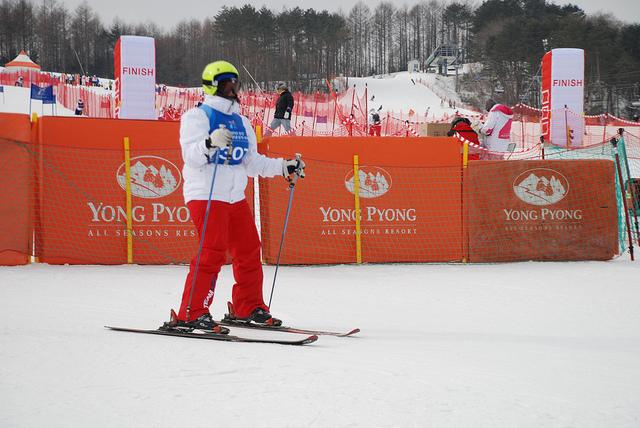Does the number on the skier start with a 3?
Be succinct. Yes. What is the wording on the barricades?
Write a very short answer. Yongpyong. Is the man snowboarding?
Concise answer only. No. 